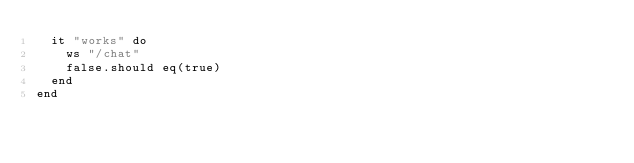<code> <loc_0><loc_0><loc_500><loc_500><_Crystal_>  it "works" do
    ws "/chat"
    false.should eq(true)
  end
end
</code> 